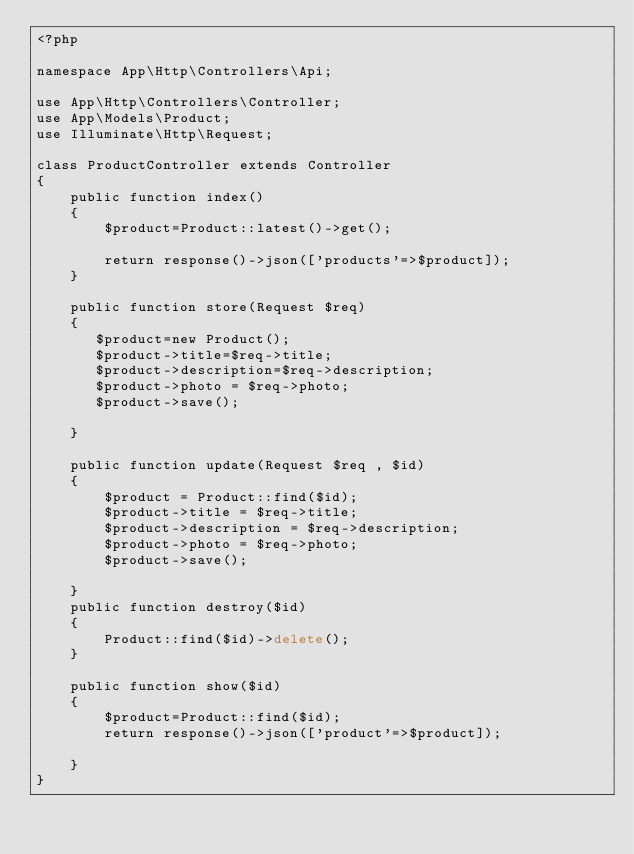<code> <loc_0><loc_0><loc_500><loc_500><_PHP_><?php

namespace App\Http\Controllers\Api;

use App\Http\Controllers\Controller;
use App\Models\Product;
use Illuminate\Http\Request;

class ProductController extends Controller
{
    public function index()
    {
        $product=Product::latest()->get();

        return response()->json(['products'=>$product]);
    }

    public function store(Request $req)
    {
       $product=new Product();
       $product->title=$req->title;
       $product->description=$req->description;
       $product->photo = $req->photo;
       $product->save();
       
    }

    public function update(Request $req , $id)
    {
        $product = Product::find($id);
        $product->title = $req->title;
        $product->description = $req->description;
        $product->photo = $req->photo;
        $product->save();
        
    }
    public function destroy($id)
    {
        Product::find($id)->delete();
    }

    public function show($id)
    {
        $product=Product::find($id);
        return response()->json(['product'=>$product]);

    }
}
</code> 